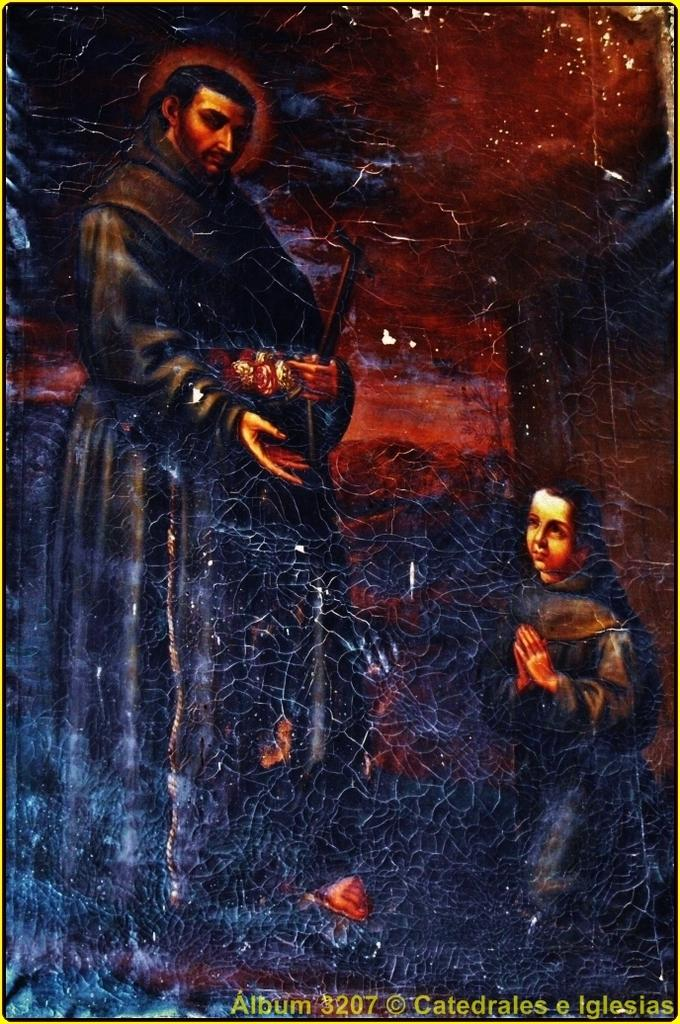Provide a one-sentence caption for the provided image. Man standing with child praying from Album 3207 Catedrales e Iglesias. 